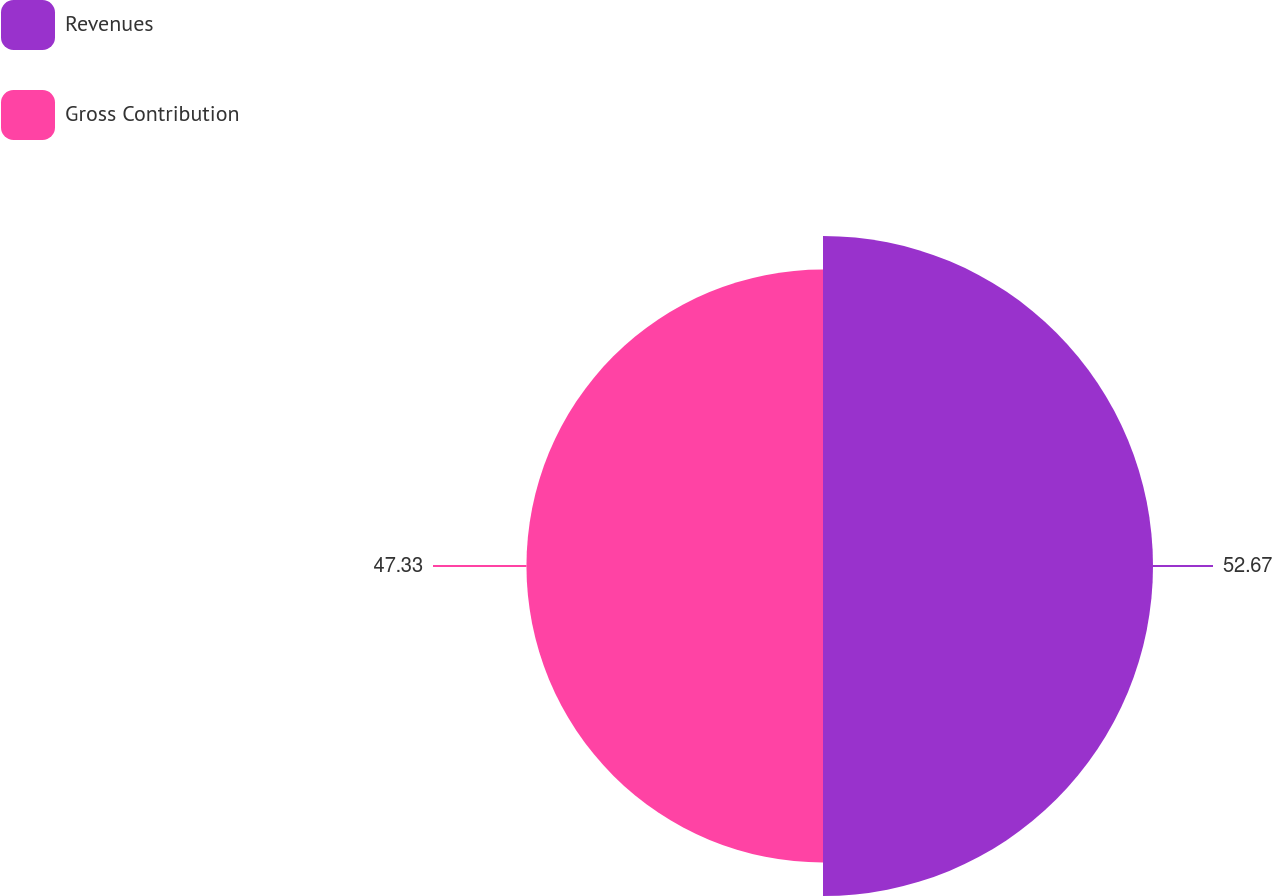Convert chart. <chart><loc_0><loc_0><loc_500><loc_500><pie_chart><fcel>Revenues<fcel>Gross Contribution<nl><fcel>52.67%<fcel>47.33%<nl></chart> 